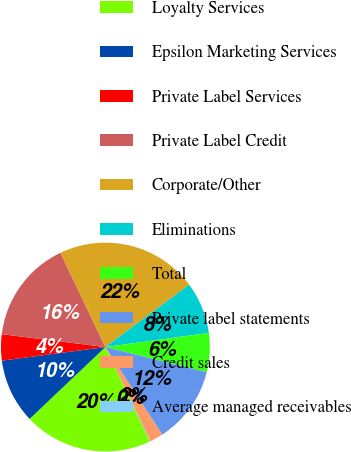<chart> <loc_0><loc_0><loc_500><loc_500><pie_chart><fcel>Loyalty Services<fcel>Epsilon Marketing Services<fcel>Private Label Services<fcel>Private Label Credit<fcel>Corporate/Other<fcel>Eliminations<fcel>Total<fcel>Private label statements<fcel>Credit sales<fcel>Average managed receivables<nl><fcel>19.92%<fcel>10.0%<fcel>4.05%<fcel>15.95%<fcel>21.9%<fcel>8.02%<fcel>6.03%<fcel>11.98%<fcel>2.07%<fcel>0.08%<nl></chart> 